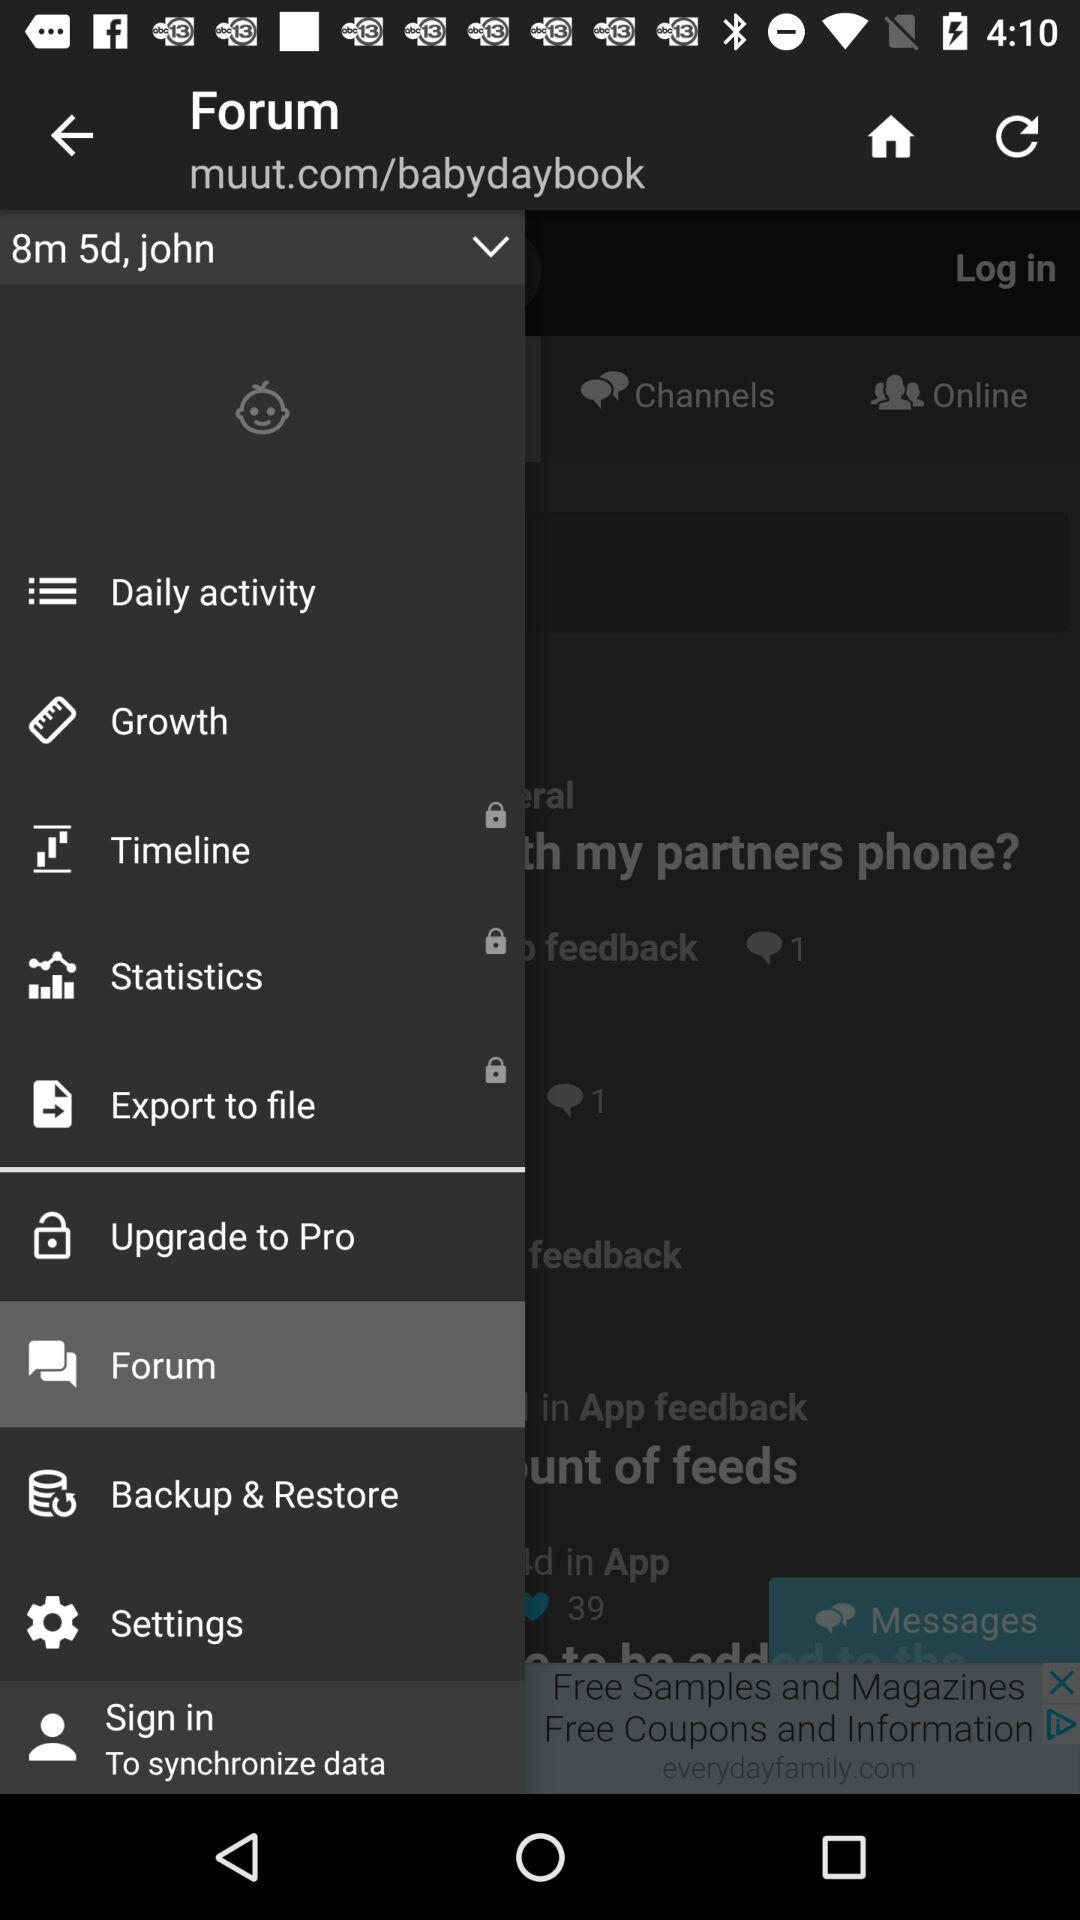How many months and days old is the baby? The baby is 8 months and 5 days old. 